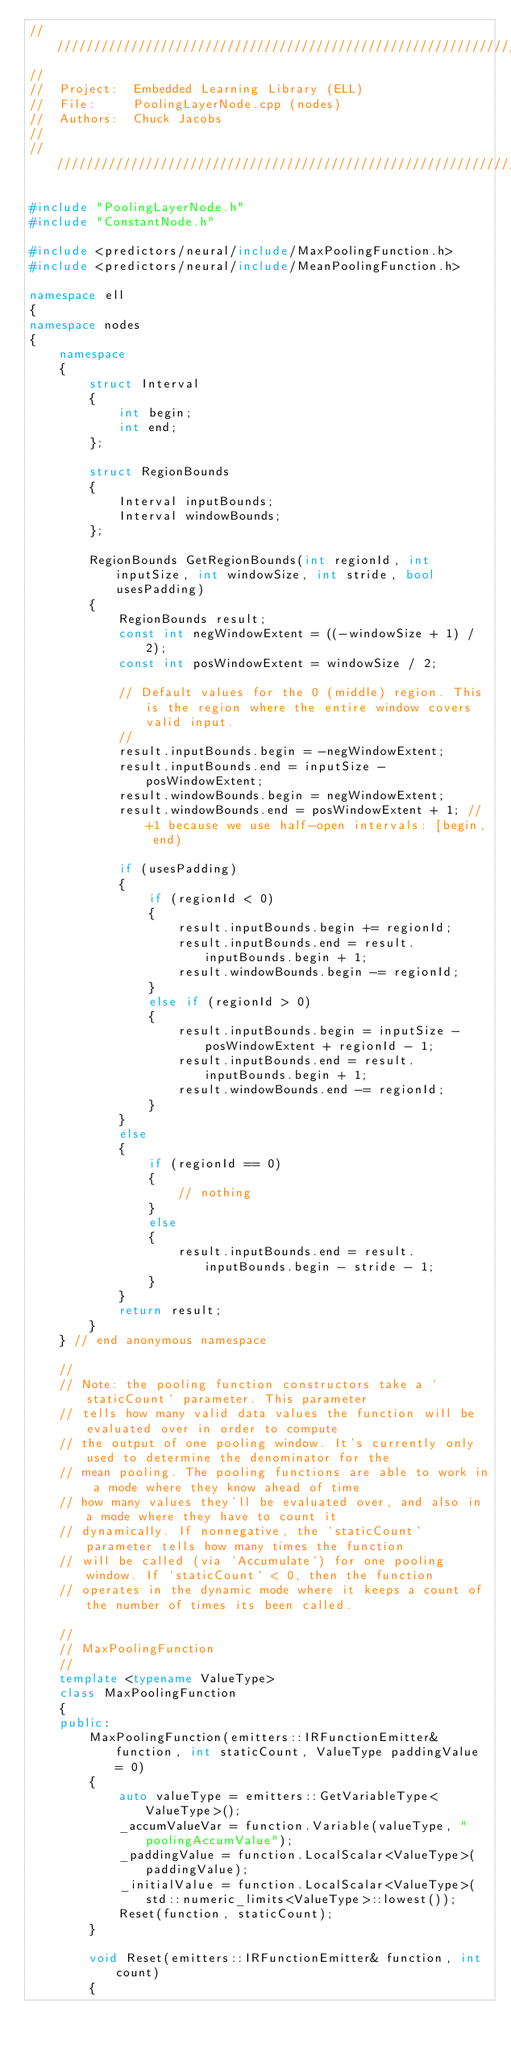Convert code to text. <code><loc_0><loc_0><loc_500><loc_500><_C++_>////////////////////////////////////////////////////////////////////////////////////////////////////
//
//  Project:  Embedded Learning Library (ELL)
//  File:     PoolingLayerNode.cpp (nodes)
//  Authors:  Chuck Jacobs
//
////////////////////////////////////////////////////////////////////////////////////////////////////

#include "PoolingLayerNode.h"
#include "ConstantNode.h"

#include <predictors/neural/include/MaxPoolingFunction.h>
#include <predictors/neural/include/MeanPoolingFunction.h>

namespace ell
{
namespace nodes
{
    namespace
    {
        struct Interval
        {
            int begin;
            int end;
        };

        struct RegionBounds
        {
            Interval inputBounds;
            Interval windowBounds;
        };

        RegionBounds GetRegionBounds(int regionId, int inputSize, int windowSize, int stride, bool usesPadding)
        {
            RegionBounds result;
            const int negWindowExtent = ((-windowSize + 1) / 2);
            const int posWindowExtent = windowSize / 2;

            // Default values for the 0 (middle) region. This is the region where the entire window covers valid input.
            //
            result.inputBounds.begin = -negWindowExtent;
            result.inputBounds.end = inputSize - posWindowExtent;
            result.windowBounds.begin = negWindowExtent;
            result.windowBounds.end = posWindowExtent + 1; // +1 because we use half-open intervals: [begin, end)

            if (usesPadding)
            {
                if (regionId < 0)
                {
                    result.inputBounds.begin += regionId;
                    result.inputBounds.end = result.inputBounds.begin + 1;
                    result.windowBounds.begin -= regionId;
                }
                else if (regionId > 0)
                {
                    result.inputBounds.begin = inputSize - posWindowExtent + regionId - 1;
                    result.inputBounds.end = result.inputBounds.begin + 1;
                    result.windowBounds.end -= regionId;
                }
            }
            else
            {
                if (regionId == 0)
                {
                    // nothing
                }
                else
                {
                    result.inputBounds.end = result.inputBounds.begin - stride - 1;
                }
            }
            return result;
        }
    } // end anonymous namespace

    //
    // Note: the pooling function constructors take a `staticCount` parameter. This parameter
    // tells how many valid data values the function will be evaluated over in order to compute
    // the output of one pooling window. It's currently only used to determine the denominator for the
    // mean pooling. The pooling functions are able to work in a mode where they know ahead of time
    // how many values they'll be evaluated over, and also in a mode where they have to count it
    // dynamically. If nonnegative, the `staticCount` parameter tells how many times the function
    // will be called (via `Accumulate`) for one pooling window. If `staticCount` < 0, then the function
    // operates in the dynamic mode where it keeps a count of the number of times its been called.

    //
    // MaxPoolingFunction
    //
    template <typename ValueType>
    class MaxPoolingFunction
    {
    public:
        MaxPoolingFunction(emitters::IRFunctionEmitter& function, int staticCount, ValueType paddingValue = 0)
        {
            auto valueType = emitters::GetVariableType<ValueType>();
            _accumValueVar = function.Variable(valueType, "poolingAccumValue");
            _paddingValue = function.LocalScalar<ValueType>(paddingValue);
            _initialValue = function.LocalScalar<ValueType>(std::numeric_limits<ValueType>::lowest());
            Reset(function, staticCount);
        }

        void Reset(emitters::IRFunctionEmitter& function, int count)
        {</code> 